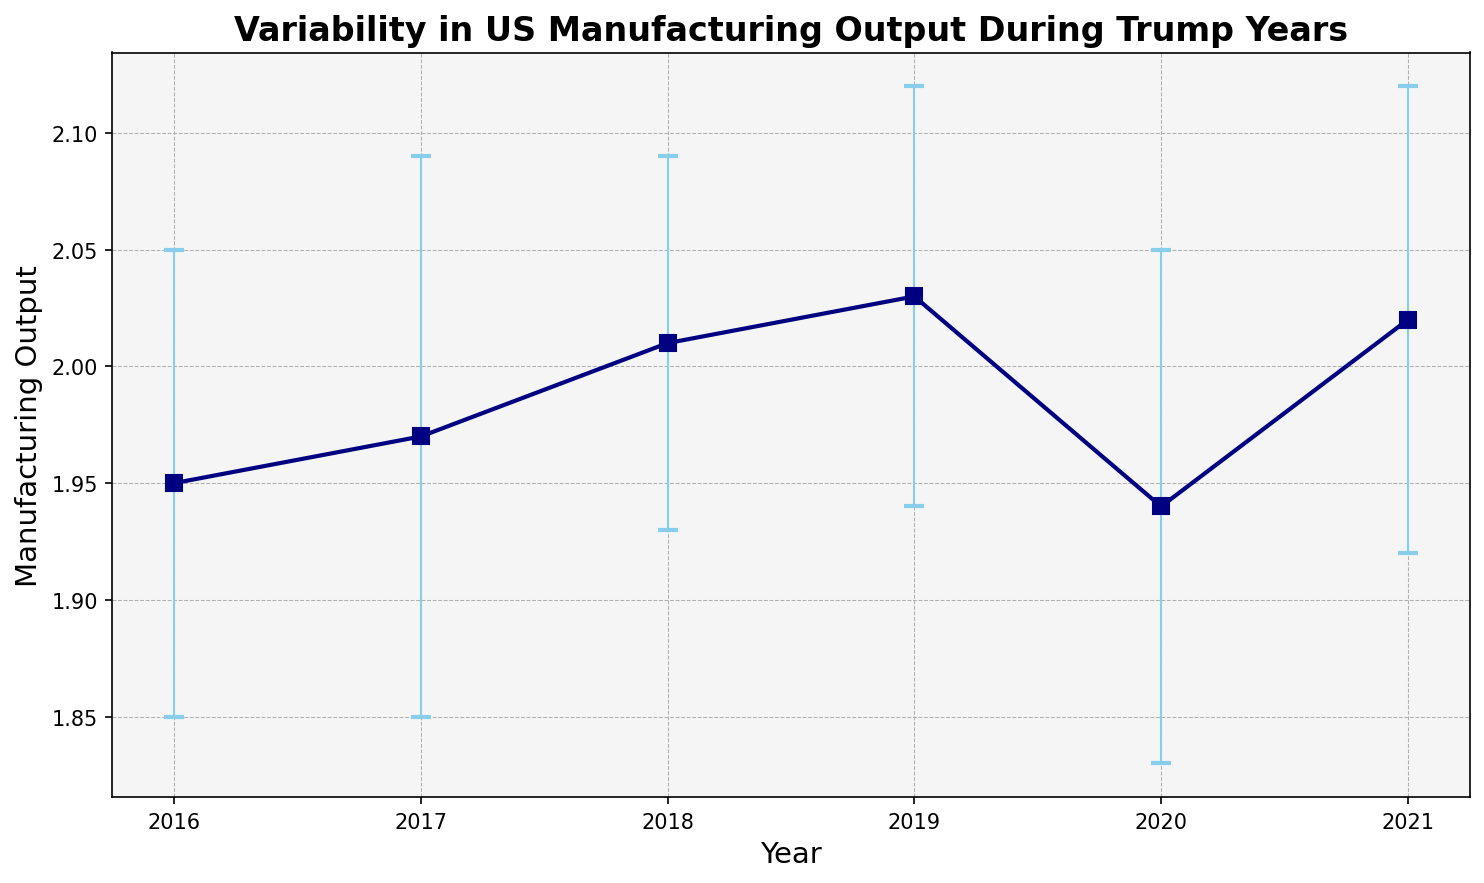Which year had the highest manufacturing output? The highest point on the y-axis corresponds to the year 2019, where the output reads 2.03
Answer: 2019 What is the difference between the highest and lowest manufacturing outputs during the displayed period? The highest output is 2.03 in 2019 and the lowest is 1.94 in 2020. The difference is 2.03 - 1.94 = 0.09
Answer: 0.09 Which year had the smallest reported error? The smallest error bar length belongs to the year 2018 with an error of 0.08
Answer: 2018 What is the average manufacturing output between 2016 and 2021? Sum the values for the years 2016 through 2021: 1.95 + 1.97 + 2.01 + 2.03 + 1.94 + 2.02 = 11.92. Divide by the number of years (6): 11.92 / 6 = 1.9867
Answer: 1.99 Which years had a manufacturing output of more than 2.00? The years with outputs above 2.00 are 2018 (2.01), 2019 (2.03), and 2021 (2.02)
Answer: 2018, 2019, 2021 How does the error in 2020 compare to the error in 2017? The error in 2020 is 0.11, while the error in 2017 is 0.12. The 2020 error is smaller than the 2017 error
Answer: 2020 < 2017 Which year shows the steepest decline in manufacturing output from the previous year? The largest drop in output is from 2019 (2.03) to 2020 (1.94), which is a difference of 2.03 - 1.94 = 0.09
Answer: 2020 What is the overall trend in manufacturing output from 2016 to 2021? The output initially rises from 1.95 in 2016 to 2.03 in 2019 before dropping slightly to 1.94 in 2020 and then rising again to 2.02 in 2021. The general trend is slightly increasing overall, ending higher than it started
Answer: Slight increase 